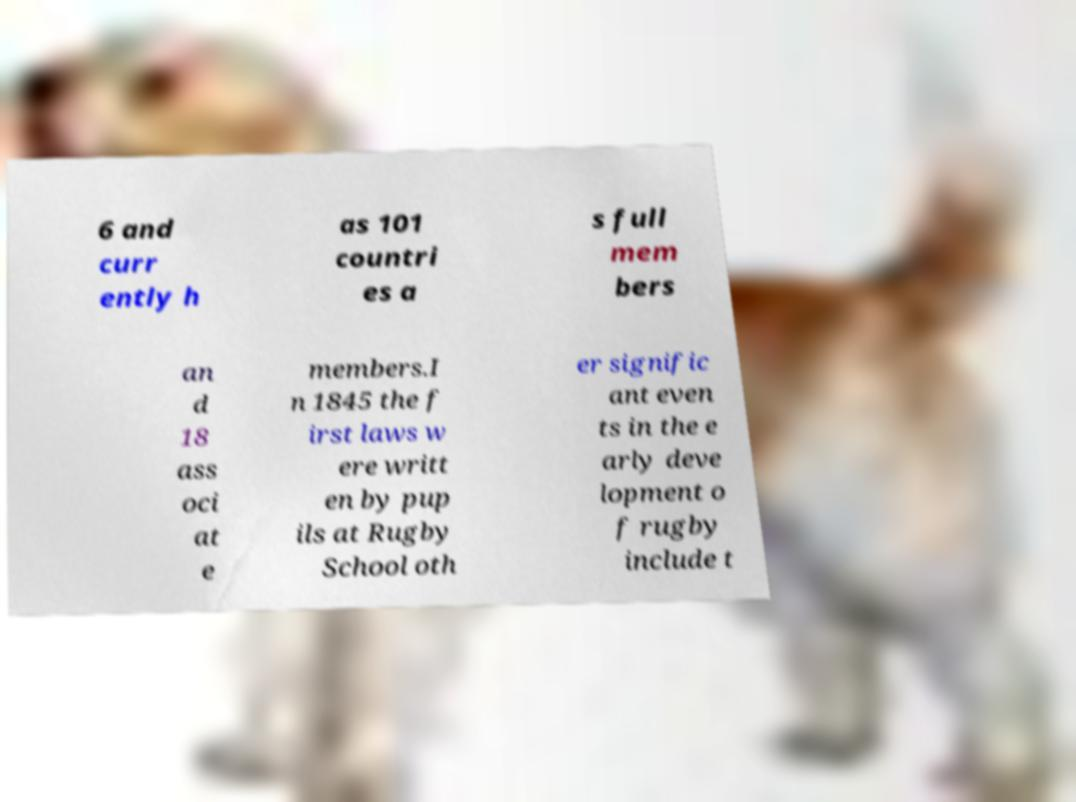Could you assist in decoding the text presented in this image and type it out clearly? 6 and curr ently h as 101 countri es a s full mem bers an d 18 ass oci at e members.I n 1845 the f irst laws w ere writt en by pup ils at Rugby School oth er signific ant even ts in the e arly deve lopment o f rugby include t 